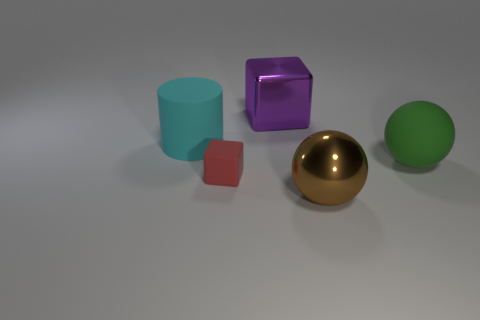Is the size of the metal thing that is in front of the red rubber object the same as the big rubber cylinder?
Offer a terse response. Yes. Is there anything else that has the same shape as the cyan rubber object?
Your answer should be compact. No. Is the red thing made of the same material as the large ball in front of the large green rubber object?
Your answer should be compact. No. How many cyan things are either cylinders or big metal balls?
Provide a short and direct response. 1. Are any large red metal cylinders visible?
Give a very brief answer. No. There is a large metallic object to the left of the large ball in front of the red object; is there a thing that is on the right side of it?
Your answer should be very brief. Yes. Are there any other things that have the same size as the rubber cube?
Your answer should be very brief. No. Is the shape of the red thing the same as the large rubber thing to the left of the green matte thing?
Your answer should be compact. No. What is the color of the big shiny thing that is behind the big rubber object to the right of the big metal thing in front of the large cube?
Offer a terse response. Purple. What number of things are either big brown objects that are in front of the cyan rubber cylinder or big objects that are in front of the tiny red object?
Ensure brevity in your answer.  1. 